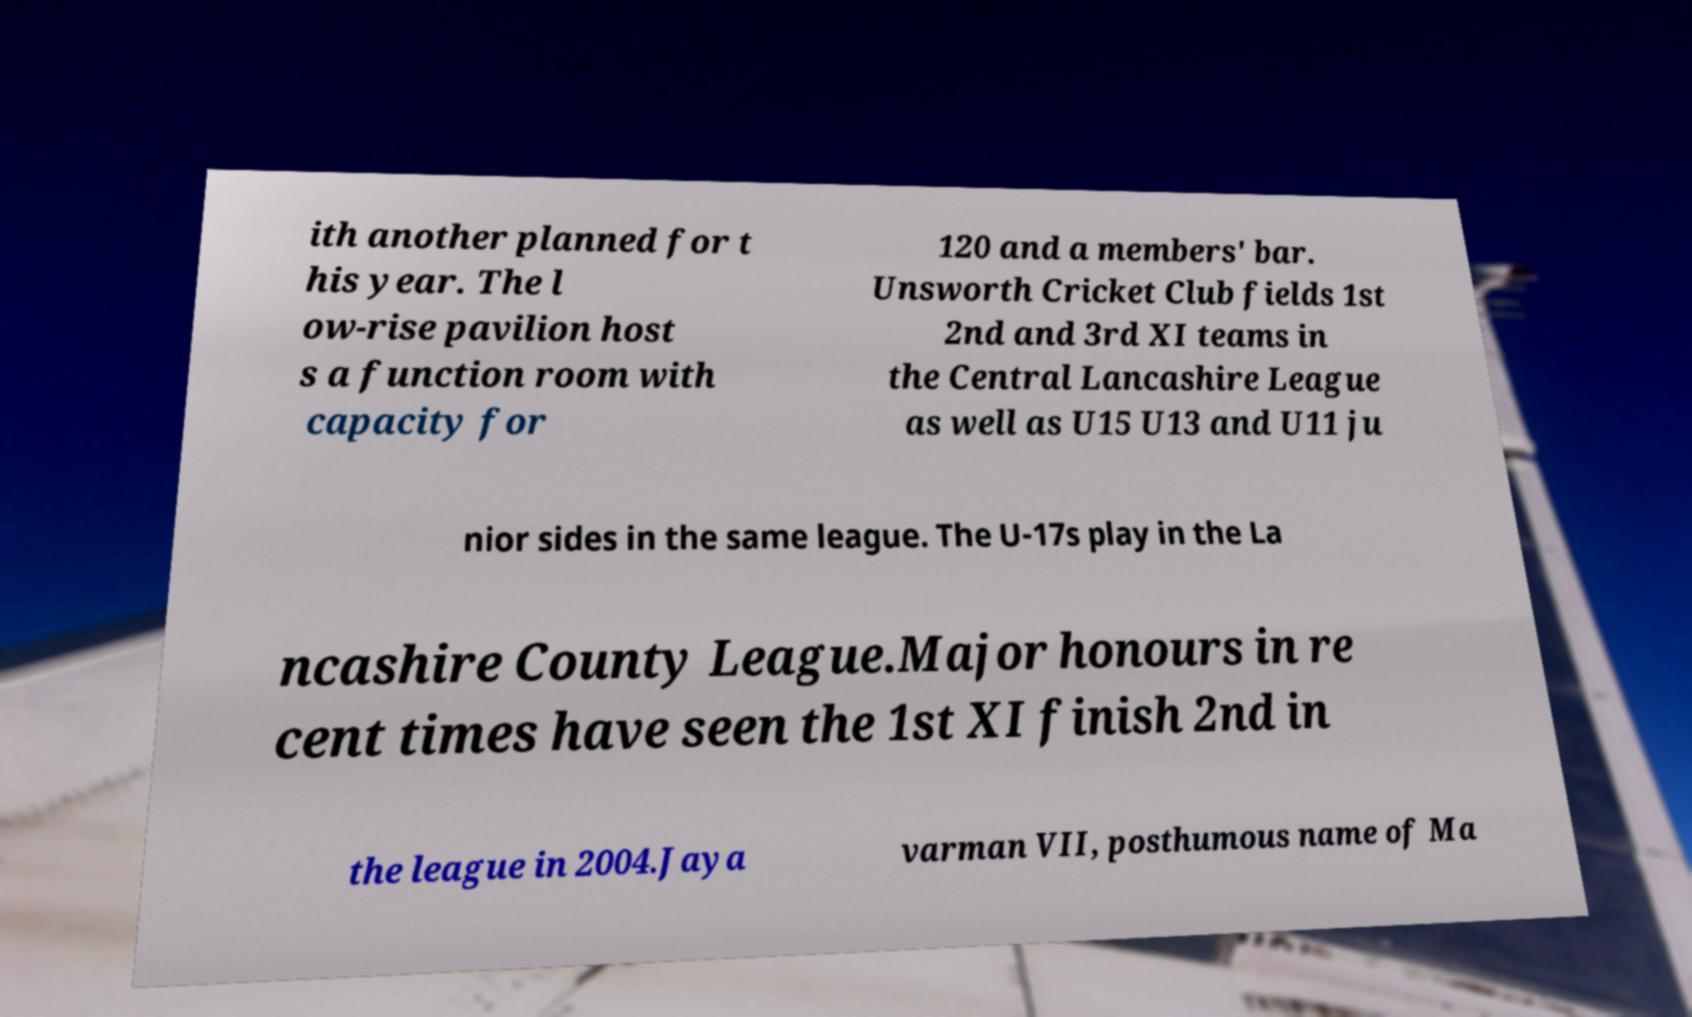There's text embedded in this image that I need extracted. Can you transcribe it verbatim? ith another planned for t his year. The l ow-rise pavilion host s a function room with capacity for 120 and a members' bar. Unsworth Cricket Club fields 1st 2nd and 3rd XI teams in the Central Lancashire League as well as U15 U13 and U11 ju nior sides in the same league. The U-17s play in the La ncashire County League.Major honours in re cent times have seen the 1st XI finish 2nd in the league in 2004.Jaya varman VII, posthumous name of Ma 